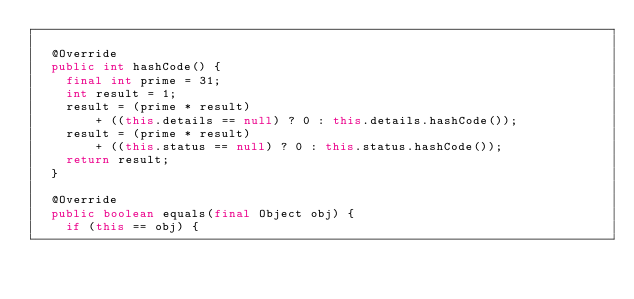<code> <loc_0><loc_0><loc_500><loc_500><_Java_>
  @Override
  public int hashCode() {
    final int prime = 31;
    int result = 1;
    result = (prime * result)
        + ((this.details == null) ? 0 : this.details.hashCode());
    result = (prime * result)
        + ((this.status == null) ? 0 : this.status.hashCode());
    return result;
  }

  @Override
  public boolean equals(final Object obj) {
    if (this == obj) {</code> 